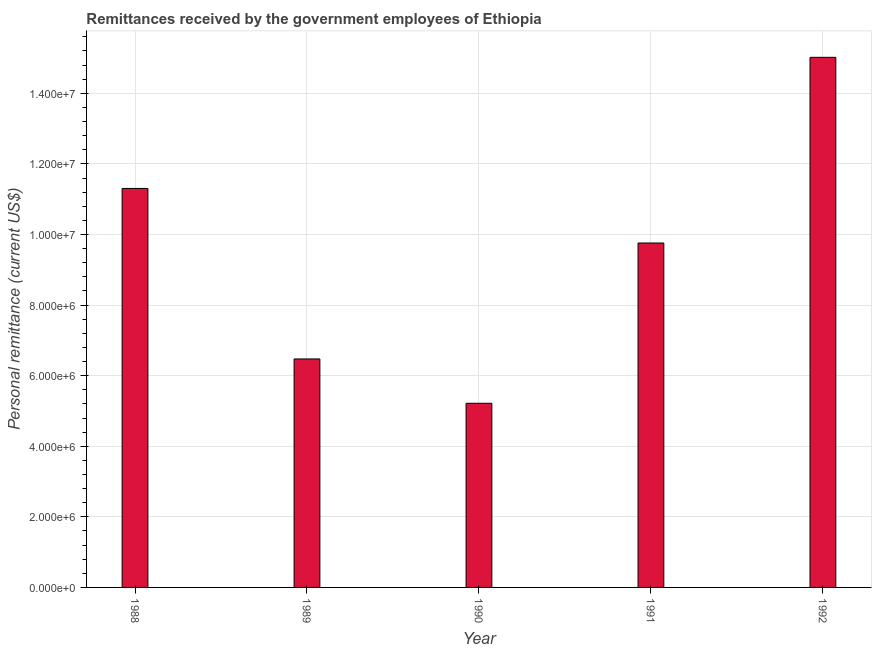Does the graph contain any zero values?
Your answer should be very brief. No. Does the graph contain grids?
Make the answer very short. Yes. What is the title of the graph?
Your answer should be compact. Remittances received by the government employees of Ethiopia. What is the label or title of the X-axis?
Your answer should be compact. Year. What is the label or title of the Y-axis?
Your answer should be very brief. Personal remittance (current US$). What is the personal remittances in 1989?
Your answer should be very brief. 6.47e+06. Across all years, what is the maximum personal remittances?
Offer a terse response. 1.50e+07. Across all years, what is the minimum personal remittances?
Ensure brevity in your answer.  5.22e+06. What is the sum of the personal remittances?
Offer a terse response. 4.78e+07. What is the difference between the personal remittances in 1989 and 1992?
Offer a very short reply. -8.55e+06. What is the average personal remittances per year?
Provide a succinct answer. 9.55e+06. What is the median personal remittances?
Keep it short and to the point. 9.76e+06. In how many years, is the personal remittances greater than 8400000 US$?
Your answer should be compact. 3. What is the ratio of the personal remittances in 1990 to that in 1992?
Make the answer very short. 0.35. Is the personal remittances in 1989 less than that in 1991?
Your answer should be compact. Yes. What is the difference between the highest and the second highest personal remittances?
Give a very brief answer. 3.71e+06. Is the sum of the personal remittances in 1988 and 1991 greater than the maximum personal remittances across all years?
Offer a terse response. Yes. What is the difference between the highest and the lowest personal remittances?
Your response must be concise. 9.80e+06. Are all the bars in the graph horizontal?
Give a very brief answer. No. How many years are there in the graph?
Ensure brevity in your answer.  5. What is the Personal remittance (current US$) in 1988?
Keep it short and to the point. 1.13e+07. What is the Personal remittance (current US$) in 1989?
Keep it short and to the point. 6.47e+06. What is the Personal remittance (current US$) of 1990?
Your response must be concise. 5.22e+06. What is the Personal remittance (current US$) of 1991?
Your response must be concise. 9.76e+06. What is the Personal remittance (current US$) in 1992?
Your answer should be very brief. 1.50e+07. What is the difference between the Personal remittance (current US$) in 1988 and 1989?
Ensure brevity in your answer.  4.83e+06. What is the difference between the Personal remittance (current US$) in 1988 and 1990?
Give a very brief answer. 6.09e+06. What is the difference between the Personal remittance (current US$) in 1988 and 1991?
Provide a succinct answer. 1.55e+06. What is the difference between the Personal remittance (current US$) in 1988 and 1992?
Provide a short and direct response. -3.71e+06. What is the difference between the Personal remittance (current US$) in 1989 and 1990?
Your response must be concise. 1.26e+06. What is the difference between the Personal remittance (current US$) in 1989 and 1991?
Keep it short and to the point. -3.29e+06. What is the difference between the Personal remittance (current US$) in 1989 and 1992?
Your response must be concise. -8.55e+06. What is the difference between the Personal remittance (current US$) in 1990 and 1991?
Your answer should be very brief. -4.54e+06. What is the difference between the Personal remittance (current US$) in 1990 and 1992?
Provide a succinct answer. -9.80e+06. What is the difference between the Personal remittance (current US$) in 1991 and 1992?
Give a very brief answer. -5.26e+06. What is the ratio of the Personal remittance (current US$) in 1988 to that in 1989?
Provide a short and direct response. 1.75. What is the ratio of the Personal remittance (current US$) in 1988 to that in 1990?
Give a very brief answer. 2.17. What is the ratio of the Personal remittance (current US$) in 1988 to that in 1991?
Offer a very short reply. 1.16. What is the ratio of the Personal remittance (current US$) in 1988 to that in 1992?
Your response must be concise. 0.75. What is the ratio of the Personal remittance (current US$) in 1989 to that in 1990?
Provide a succinct answer. 1.24. What is the ratio of the Personal remittance (current US$) in 1989 to that in 1991?
Give a very brief answer. 0.66. What is the ratio of the Personal remittance (current US$) in 1989 to that in 1992?
Your response must be concise. 0.43. What is the ratio of the Personal remittance (current US$) in 1990 to that in 1991?
Offer a very short reply. 0.54. What is the ratio of the Personal remittance (current US$) in 1990 to that in 1992?
Make the answer very short. 0.35. What is the ratio of the Personal remittance (current US$) in 1991 to that in 1992?
Offer a very short reply. 0.65. 